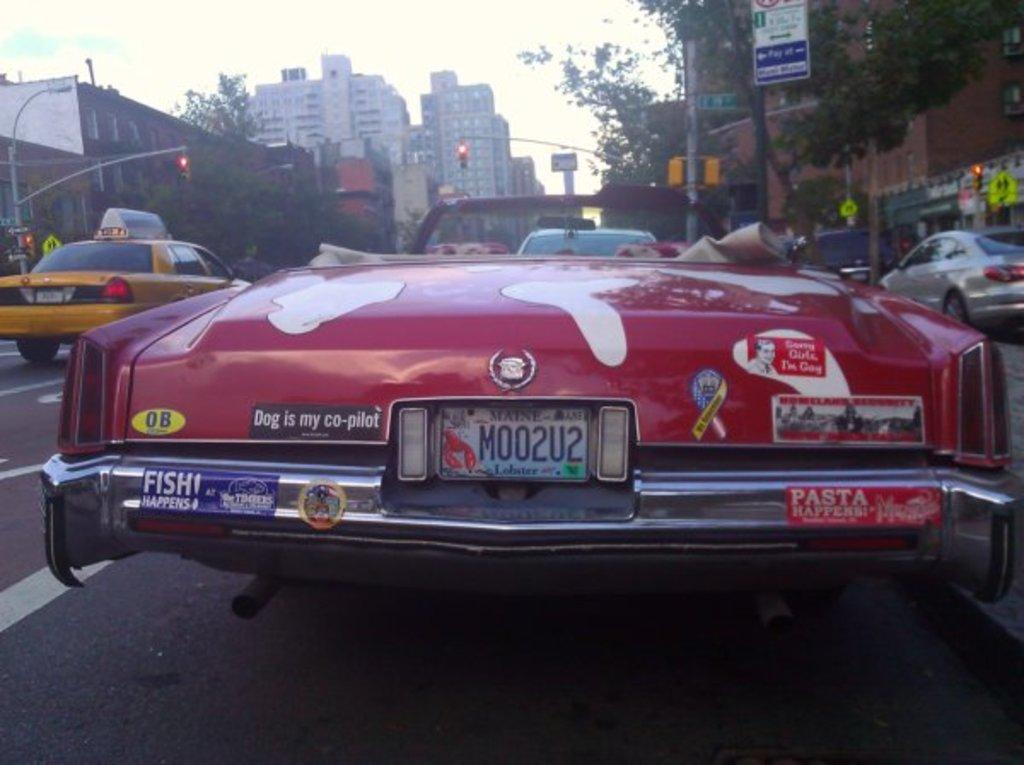<image>
Offer a succinct explanation of the picture presented. A red car with the license plate Moo2u2. 